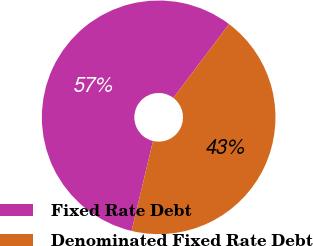<chart> <loc_0><loc_0><loc_500><loc_500><pie_chart><fcel>Fixed Rate Debt<fcel>Denominated Fixed Rate Debt<nl><fcel>56.57%<fcel>43.43%<nl></chart> 